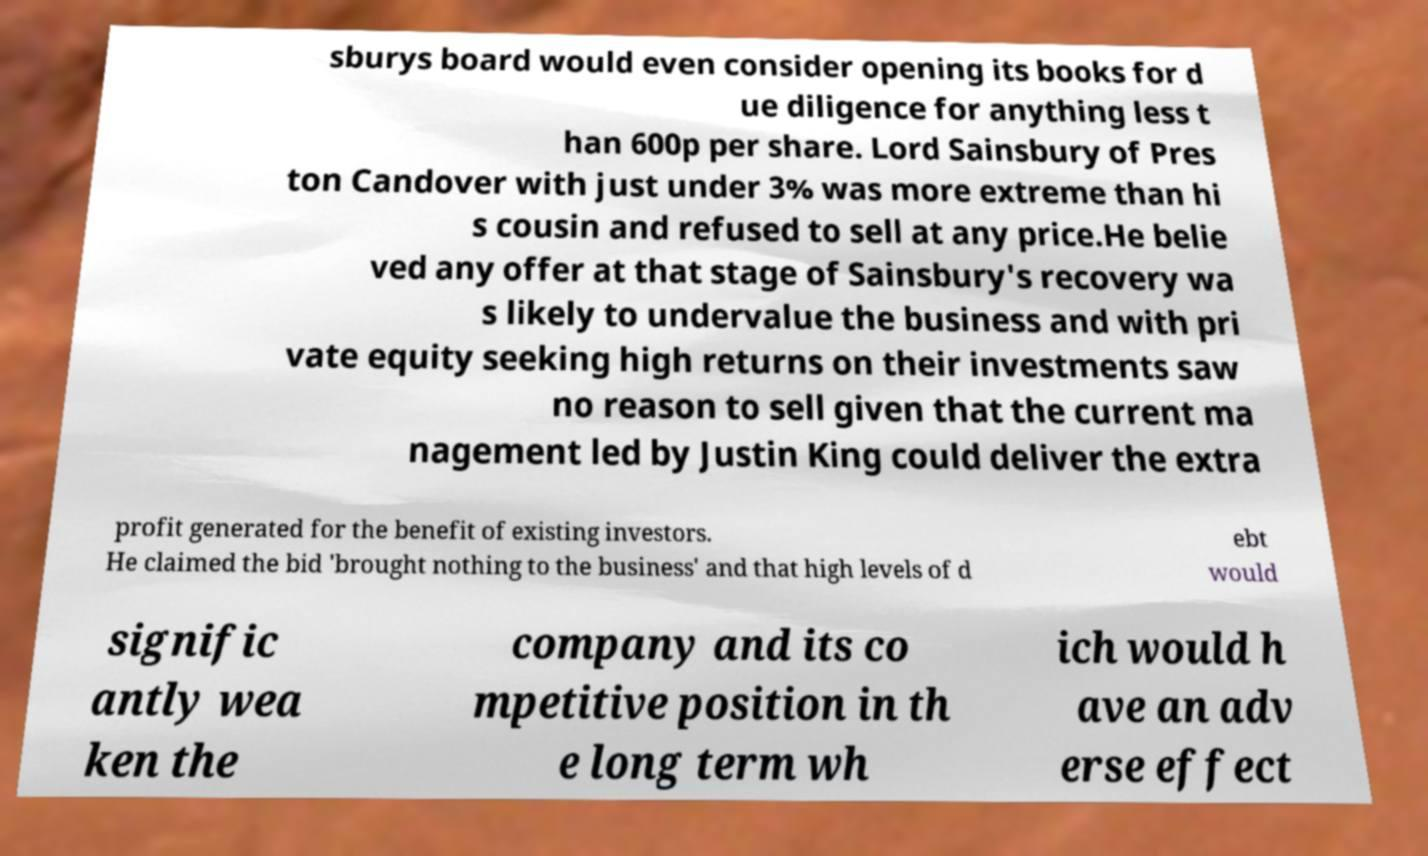Please read and relay the text visible in this image. What does it say? sburys board would even consider opening its books for d ue diligence for anything less t han 600p per share. Lord Sainsbury of Pres ton Candover with just under 3% was more extreme than hi s cousin and refused to sell at any price.He belie ved any offer at that stage of Sainsbury's recovery wa s likely to undervalue the business and with pri vate equity seeking high returns on their investments saw no reason to sell given that the current ma nagement led by Justin King could deliver the extra profit generated for the benefit of existing investors. He claimed the bid 'brought nothing to the business' and that high levels of d ebt would signific antly wea ken the company and its co mpetitive position in th e long term wh ich would h ave an adv erse effect 